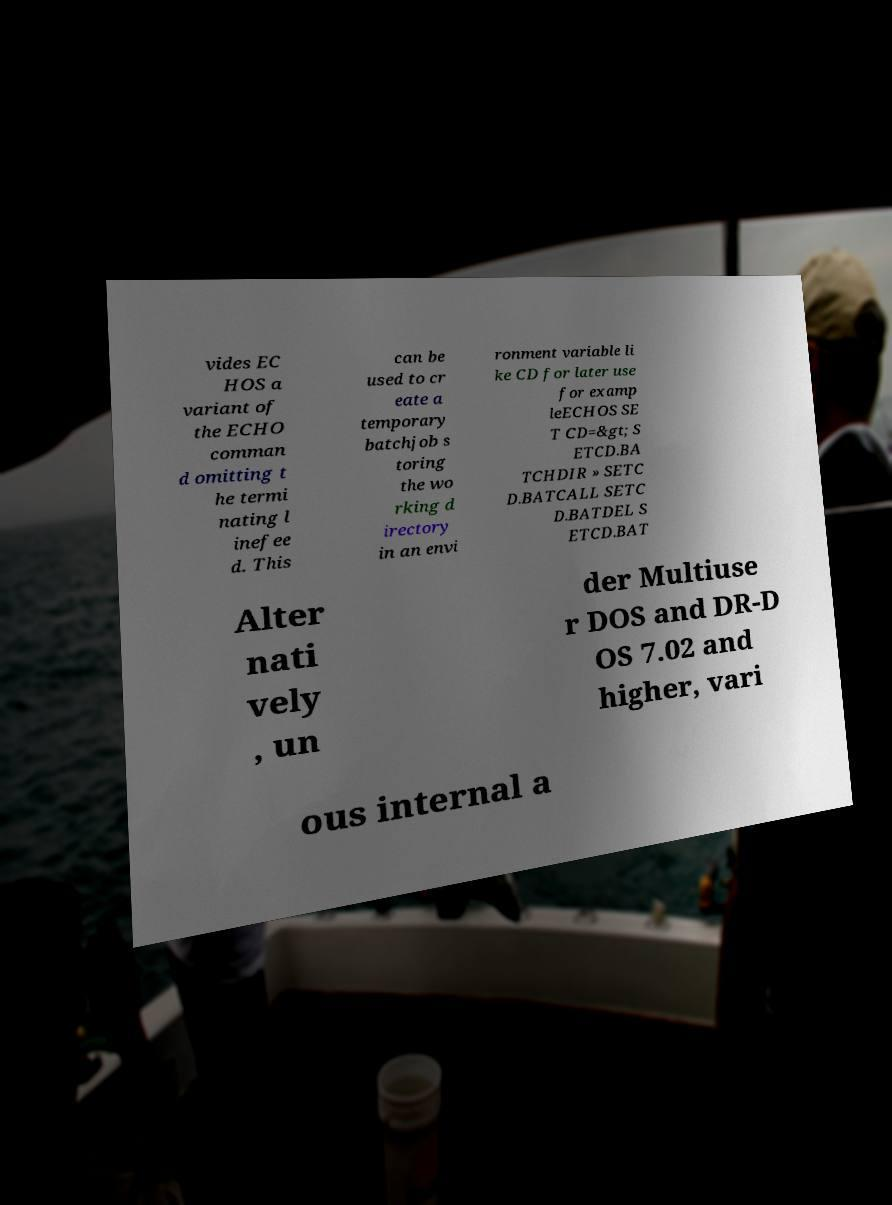I need the written content from this picture converted into text. Can you do that? vides EC HOS a variant of the ECHO comman d omitting t he termi nating l inefee d. This can be used to cr eate a temporary batchjob s toring the wo rking d irectory in an envi ronment variable li ke CD for later use for examp leECHOS SE T CD=&gt; S ETCD.BA TCHDIR » SETC D.BATCALL SETC D.BATDEL S ETCD.BAT Alter nati vely , un der Multiuse r DOS and DR-D OS 7.02 and higher, vari ous internal a 